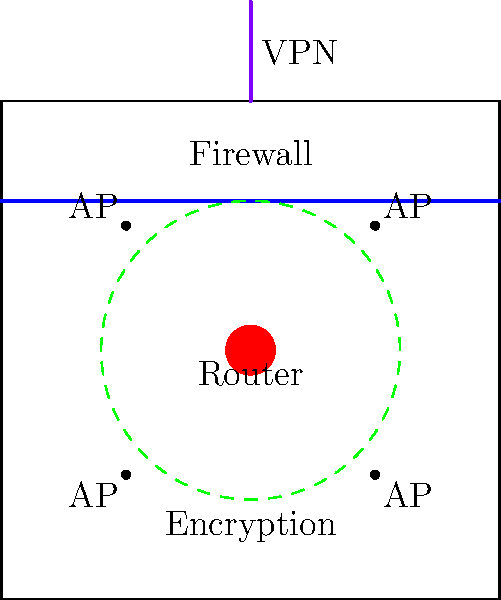Based on the graphical representation of wireless network security measures for the office premises, which component is responsible for encrypting data transmitted over the wireless network? To answer this question, let's analyze the components in the diagram:

1. The red circle at the center represents the wireless router, which is the central hub for the network.
2. The blue line across the top of the office layout represents the firewall, which protects the network from external threats.
3. The purple line extending beyond the office perimeter represents a VPN (Virtual Private Network) connection for secure remote access.
4. The four dots in the corners labeled "AP" represent wireless access points for extended coverage.
5. The green dashed circle surrounding the router represents encryption.

The key to this question lies in understanding the function of encryption in wireless networks. Encryption is the process of encoding data to protect it from unauthorized access during transmission. In a wireless network, encryption is crucial because data is transmitted through the air, making it vulnerable to interception.

The green dashed circle in the diagram represents the encryption zone, encompassing the entire office space. This indicates that all data transmitted within the wireless network is encrypted, regardless of which access point a device connects to.

Therefore, the component responsible for encrypting data transmitted over the wireless network is the encryption system represented by the green dashed circle.
Answer: Encryption (green dashed circle) 